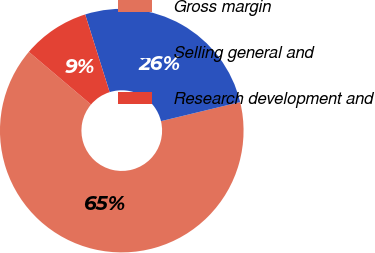<chart> <loc_0><loc_0><loc_500><loc_500><pie_chart><fcel>Gross margin<fcel>Selling general and<fcel>Research development and<nl><fcel>64.96%<fcel>26.09%<fcel>8.95%<nl></chart> 